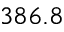<formula> <loc_0><loc_0><loc_500><loc_500>3 8 6 . 8</formula> 